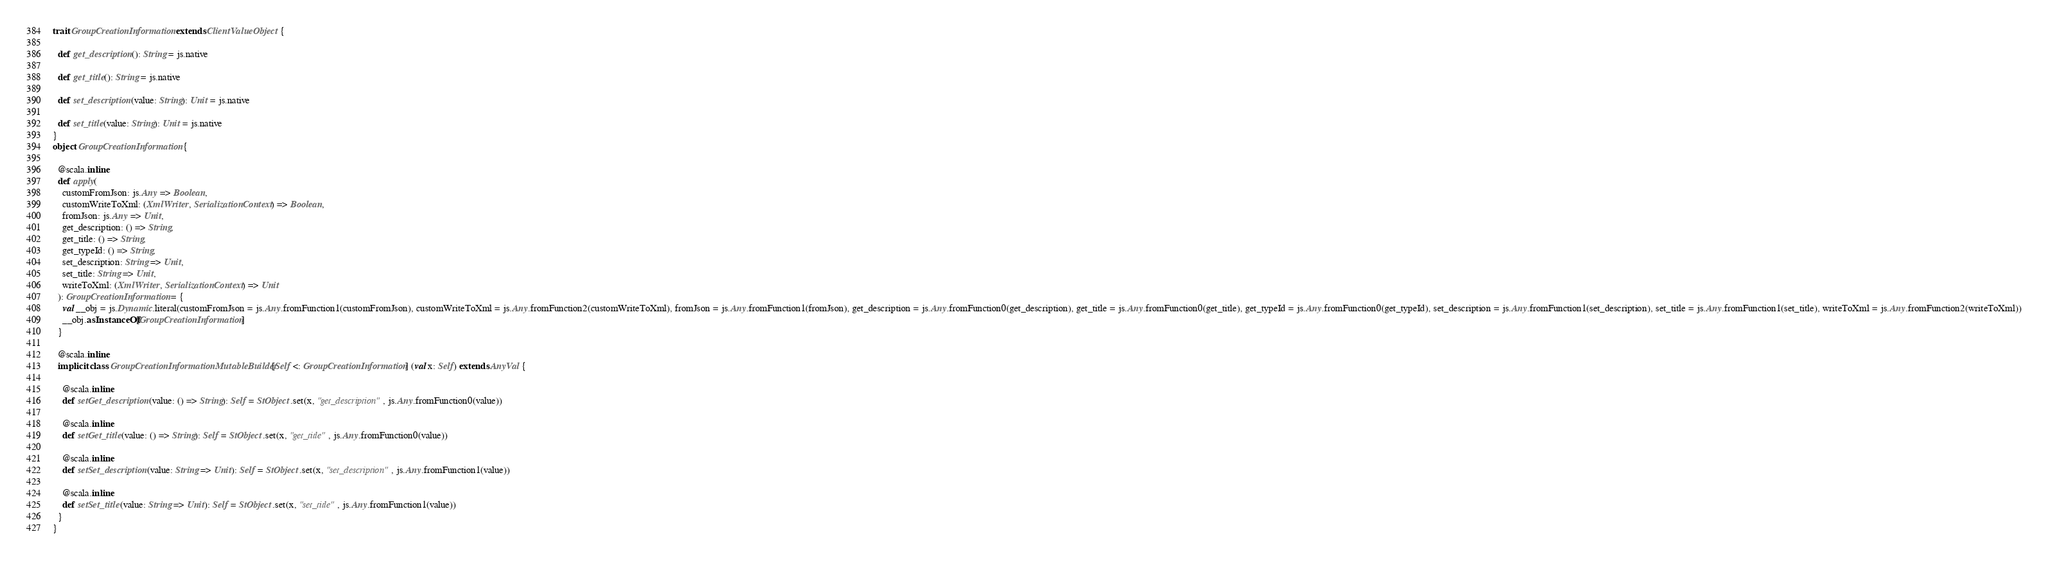<code> <loc_0><loc_0><loc_500><loc_500><_Scala_>trait GroupCreationInformation extends ClientValueObject {
  
  def get_description(): String = js.native
  
  def get_title(): String = js.native
  
  def set_description(value: String): Unit = js.native
  
  def set_title(value: String): Unit = js.native
}
object GroupCreationInformation {
  
  @scala.inline
  def apply(
    customFromJson: js.Any => Boolean,
    customWriteToXml: (XmlWriter, SerializationContext) => Boolean,
    fromJson: js.Any => Unit,
    get_description: () => String,
    get_title: () => String,
    get_typeId: () => String,
    set_description: String => Unit,
    set_title: String => Unit,
    writeToXml: (XmlWriter, SerializationContext) => Unit
  ): GroupCreationInformation = {
    val __obj = js.Dynamic.literal(customFromJson = js.Any.fromFunction1(customFromJson), customWriteToXml = js.Any.fromFunction2(customWriteToXml), fromJson = js.Any.fromFunction1(fromJson), get_description = js.Any.fromFunction0(get_description), get_title = js.Any.fromFunction0(get_title), get_typeId = js.Any.fromFunction0(get_typeId), set_description = js.Any.fromFunction1(set_description), set_title = js.Any.fromFunction1(set_title), writeToXml = js.Any.fromFunction2(writeToXml))
    __obj.asInstanceOf[GroupCreationInformation]
  }
  
  @scala.inline
  implicit class GroupCreationInformationMutableBuilder[Self <: GroupCreationInformation] (val x: Self) extends AnyVal {
    
    @scala.inline
    def setGet_description(value: () => String): Self = StObject.set(x, "get_description", js.Any.fromFunction0(value))
    
    @scala.inline
    def setGet_title(value: () => String): Self = StObject.set(x, "get_title", js.Any.fromFunction0(value))
    
    @scala.inline
    def setSet_description(value: String => Unit): Self = StObject.set(x, "set_description", js.Any.fromFunction1(value))
    
    @scala.inline
    def setSet_title(value: String => Unit): Self = StObject.set(x, "set_title", js.Any.fromFunction1(value))
  }
}
</code> 